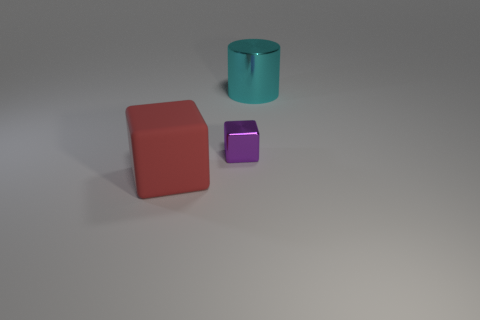What number of other things are the same color as the big rubber object?
Your answer should be compact. 0. Is the material of the big object behind the large matte object the same as the small object?
Offer a very short reply. Yes. There is a big object that is behind the big object in front of the object on the right side of the tiny purple cube; what shape is it?
Your answer should be very brief. Cylinder. Are there any matte blocks of the same size as the cylinder?
Ensure brevity in your answer.  Yes. What size is the purple block?
Provide a short and direct response. Small. What number of metallic cubes have the same size as the red thing?
Provide a succinct answer. 0. Is the number of big cyan shiny objects in front of the large red thing less than the number of large red objects behind the large cyan cylinder?
Your answer should be very brief. No. How big is the metallic object that is right of the metallic thing left of the large object that is behind the red rubber object?
Ensure brevity in your answer.  Large. There is a thing that is in front of the cyan cylinder and behind the rubber thing; what size is it?
Make the answer very short. Small. What is the shape of the large object on the right side of the large thing to the left of the shiny cylinder?
Ensure brevity in your answer.  Cylinder. 